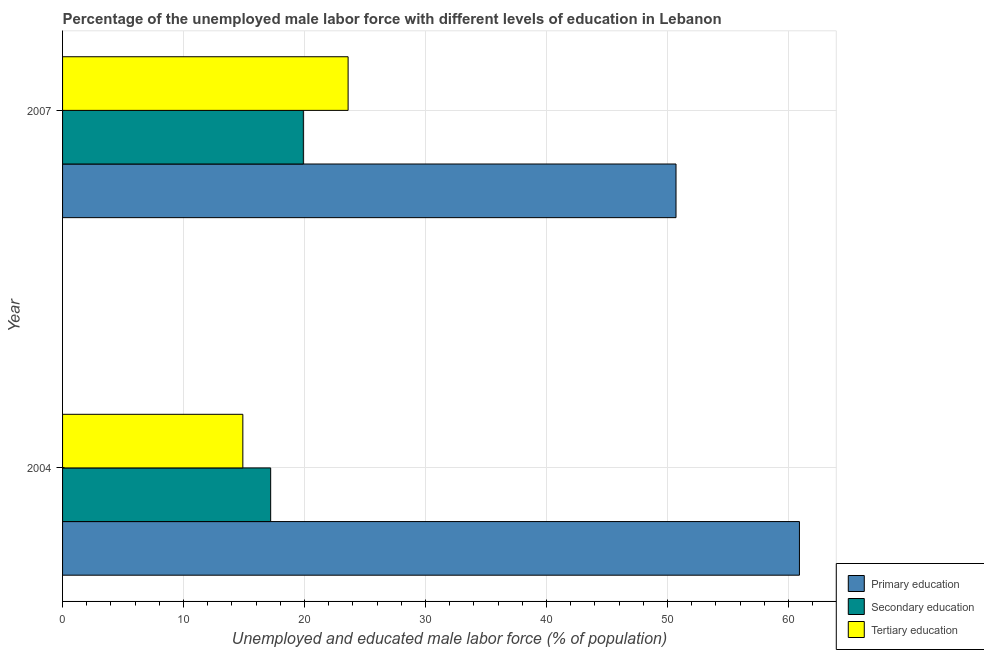How many groups of bars are there?
Your answer should be very brief. 2. How many bars are there on the 1st tick from the bottom?
Your answer should be compact. 3. What is the label of the 1st group of bars from the top?
Your answer should be compact. 2007. In how many cases, is the number of bars for a given year not equal to the number of legend labels?
Your answer should be compact. 0. What is the percentage of male labor force who received primary education in 2007?
Provide a short and direct response. 50.7. Across all years, what is the maximum percentage of male labor force who received primary education?
Your answer should be compact. 60.9. Across all years, what is the minimum percentage of male labor force who received secondary education?
Keep it short and to the point. 17.2. In which year was the percentage of male labor force who received primary education maximum?
Keep it short and to the point. 2004. In which year was the percentage of male labor force who received tertiary education minimum?
Give a very brief answer. 2004. What is the total percentage of male labor force who received tertiary education in the graph?
Your response must be concise. 38.5. What is the difference between the percentage of male labor force who received primary education in 2004 and the percentage of male labor force who received secondary education in 2007?
Your response must be concise. 41. What is the average percentage of male labor force who received tertiary education per year?
Give a very brief answer. 19.25. In the year 2004, what is the difference between the percentage of male labor force who received tertiary education and percentage of male labor force who received secondary education?
Your response must be concise. -2.3. In how many years, is the percentage of male labor force who received secondary education greater than 30 %?
Your response must be concise. 0. What is the ratio of the percentage of male labor force who received tertiary education in 2004 to that in 2007?
Your answer should be very brief. 0.63. Is the percentage of male labor force who received primary education in 2004 less than that in 2007?
Give a very brief answer. No. What does the 2nd bar from the bottom in 2007 represents?
Provide a short and direct response. Secondary education. Is it the case that in every year, the sum of the percentage of male labor force who received primary education and percentage of male labor force who received secondary education is greater than the percentage of male labor force who received tertiary education?
Your response must be concise. Yes. How many bars are there?
Your answer should be very brief. 6. Are all the bars in the graph horizontal?
Provide a short and direct response. Yes. How many years are there in the graph?
Make the answer very short. 2. Are the values on the major ticks of X-axis written in scientific E-notation?
Offer a very short reply. No. Does the graph contain grids?
Offer a very short reply. Yes. Where does the legend appear in the graph?
Provide a short and direct response. Bottom right. How many legend labels are there?
Make the answer very short. 3. What is the title of the graph?
Keep it short and to the point. Percentage of the unemployed male labor force with different levels of education in Lebanon. Does "Services" appear as one of the legend labels in the graph?
Keep it short and to the point. No. What is the label or title of the X-axis?
Give a very brief answer. Unemployed and educated male labor force (% of population). What is the label or title of the Y-axis?
Ensure brevity in your answer.  Year. What is the Unemployed and educated male labor force (% of population) in Primary education in 2004?
Provide a succinct answer. 60.9. What is the Unemployed and educated male labor force (% of population) in Secondary education in 2004?
Offer a very short reply. 17.2. What is the Unemployed and educated male labor force (% of population) of Tertiary education in 2004?
Your answer should be compact. 14.9. What is the Unemployed and educated male labor force (% of population) of Primary education in 2007?
Your answer should be very brief. 50.7. What is the Unemployed and educated male labor force (% of population) of Secondary education in 2007?
Offer a very short reply. 19.9. What is the Unemployed and educated male labor force (% of population) of Tertiary education in 2007?
Ensure brevity in your answer.  23.6. Across all years, what is the maximum Unemployed and educated male labor force (% of population) in Primary education?
Your answer should be compact. 60.9. Across all years, what is the maximum Unemployed and educated male labor force (% of population) of Secondary education?
Keep it short and to the point. 19.9. Across all years, what is the maximum Unemployed and educated male labor force (% of population) in Tertiary education?
Give a very brief answer. 23.6. Across all years, what is the minimum Unemployed and educated male labor force (% of population) of Primary education?
Your answer should be compact. 50.7. Across all years, what is the minimum Unemployed and educated male labor force (% of population) in Secondary education?
Your response must be concise. 17.2. Across all years, what is the minimum Unemployed and educated male labor force (% of population) of Tertiary education?
Keep it short and to the point. 14.9. What is the total Unemployed and educated male labor force (% of population) of Primary education in the graph?
Your answer should be compact. 111.6. What is the total Unemployed and educated male labor force (% of population) in Secondary education in the graph?
Provide a succinct answer. 37.1. What is the total Unemployed and educated male labor force (% of population) in Tertiary education in the graph?
Offer a very short reply. 38.5. What is the difference between the Unemployed and educated male labor force (% of population) in Secondary education in 2004 and that in 2007?
Your answer should be very brief. -2.7. What is the difference between the Unemployed and educated male labor force (% of population) of Primary education in 2004 and the Unemployed and educated male labor force (% of population) of Tertiary education in 2007?
Your answer should be very brief. 37.3. What is the average Unemployed and educated male labor force (% of population) of Primary education per year?
Keep it short and to the point. 55.8. What is the average Unemployed and educated male labor force (% of population) in Secondary education per year?
Provide a short and direct response. 18.55. What is the average Unemployed and educated male labor force (% of population) in Tertiary education per year?
Provide a succinct answer. 19.25. In the year 2004, what is the difference between the Unemployed and educated male labor force (% of population) of Primary education and Unemployed and educated male labor force (% of population) of Secondary education?
Provide a short and direct response. 43.7. In the year 2004, what is the difference between the Unemployed and educated male labor force (% of population) in Primary education and Unemployed and educated male labor force (% of population) in Tertiary education?
Ensure brevity in your answer.  46. In the year 2007, what is the difference between the Unemployed and educated male labor force (% of population) of Primary education and Unemployed and educated male labor force (% of population) of Secondary education?
Give a very brief answer. 30.8. In the year 2007, what is the difference between the Unemployed and educated male labor force (% of population) in Primary education and Unemployed and educated male labor force (% of population) in Tertiary education?
Ensure brevity in your answer.  27.1. What is the ratio of the Unemployed and educated male labor force (% of population) in Primary education in 2004 to that in 2007?
Your answer should be compact. 1.2. What is the ratio of the Unemployed and educated male labor force (% of population) in Secondary education in 2004 to that in 2007?
Keep it short and to the point. 0.86. What is the ratio of the Unemployed and educated male labor force (% of population) in Tertiary education in 2004 to that in 2007?
Keep it short and to the point. 0.63. What is the difference between the highest and the second highest Unemployed and educated male labor force (% of population) of Primary education?
Provide a succinct answer. 10.2. What is the difference between the highest and the second highest Unemployed and educated male labor force (% of population) in Tertiary education?
Provide a short and direct response. 8.7. What is the difference between the highest and the lowest Unemployed and educated male labor force (% of population) of Primary education?
Your answer should be compact. 10.2. 